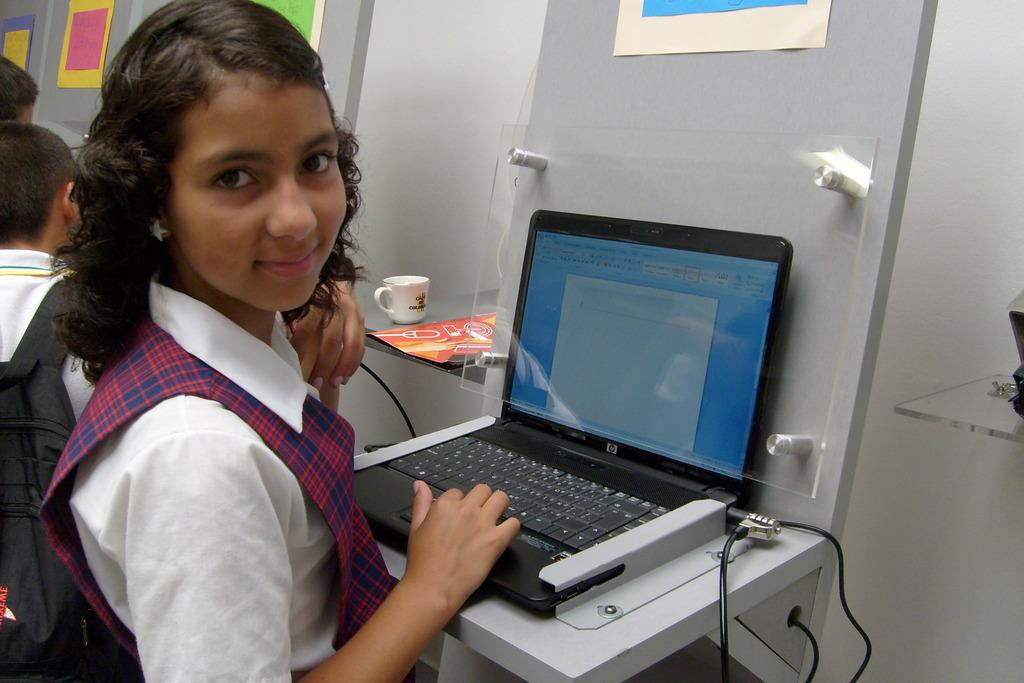<image>
Relay a brief, clear account of the picture shown. A young student sits at an open HP laptop. 